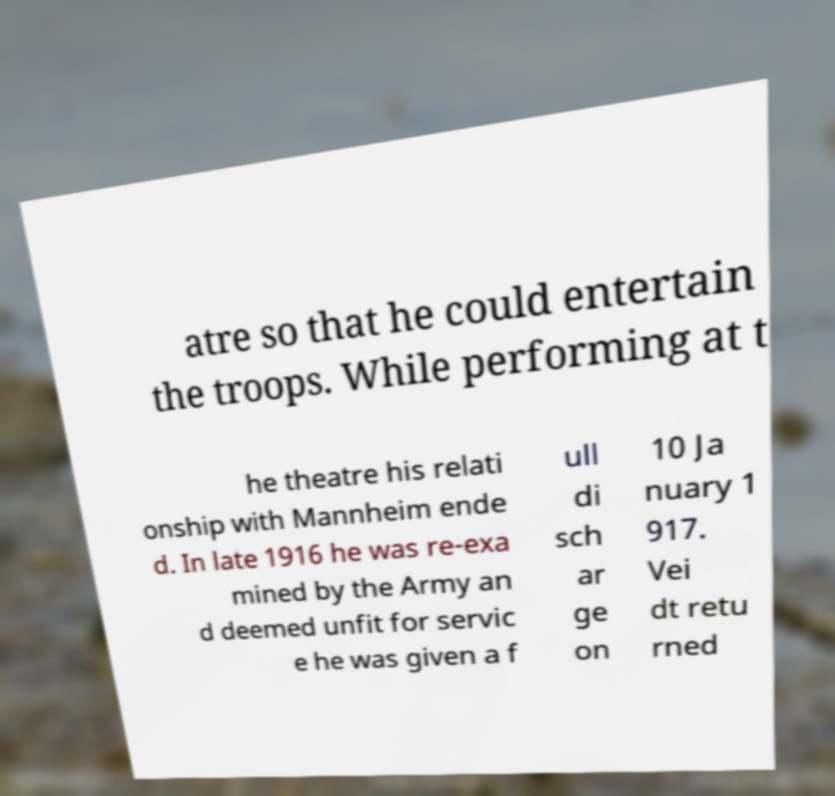Can you read and provide the text displayed in the image?This photo seems to have some interesting text. Can you extract and type it out for me? atre so that he could entertain the troops. While performing at t he theatre his relati onship with Mannheim ende d. In late 1916 he was re-exa mined by the Army an d deemed unfit for servic e he was given a f ull di sch ar ge on 10 Ja nuary 1 917. Vei dt retu rned 